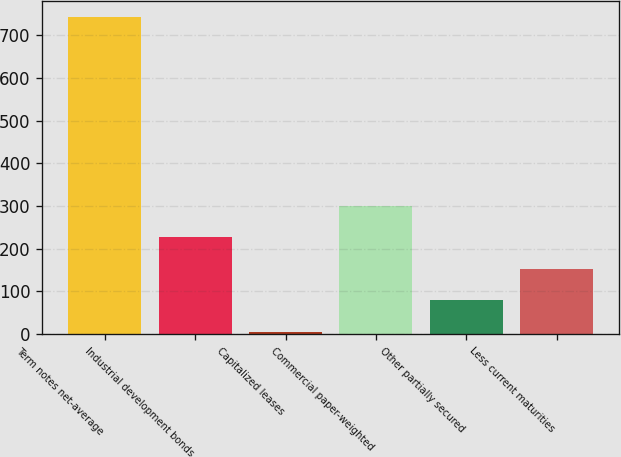Convert chart to OTSL. <chart><loc_0><loc_0><loc_500><loc_500><bar_chart><fcel>Term notes net-average<fcel>Industrial development bonds<fcel>Capitalized leases<fcel>Commercial paper-weighted<fcel>Other partially secured<fcel>Less current maturities<nl><fcel>742.5<fcel>226.25<fcel>5<fcel>300<fcel>78.75<fcel>152.5<nl></chart> 